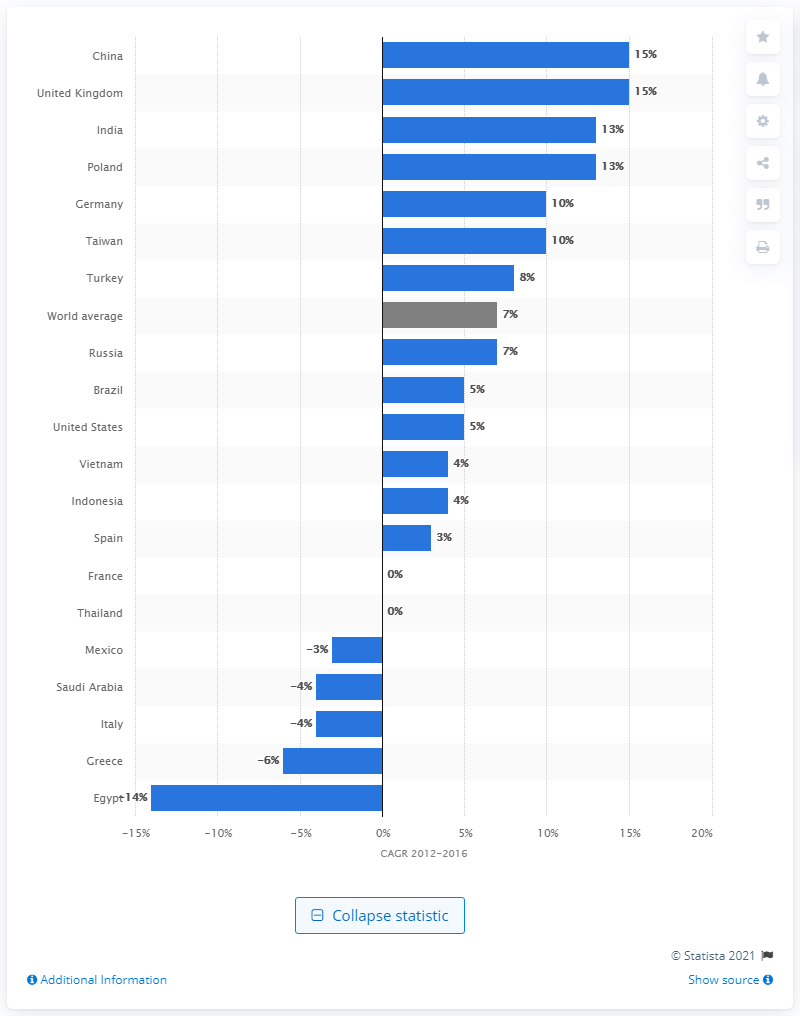Indicate a few pertinent items in this graphic. The average annual growth rate of albumin per capita consumption in Taiwan between 2012 and 2016 was 10%. The per capita consumption of albumin in the United States grew at an average rate of approximately 10% between 2012 and 2016. 